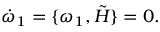<formula> <loc_0><loc_0><loc_500><loc_500>\dot { \omega } _ { 1 } = \{ \omega _ { 1 } , \tilde { H } \} = 0 .</formula> 